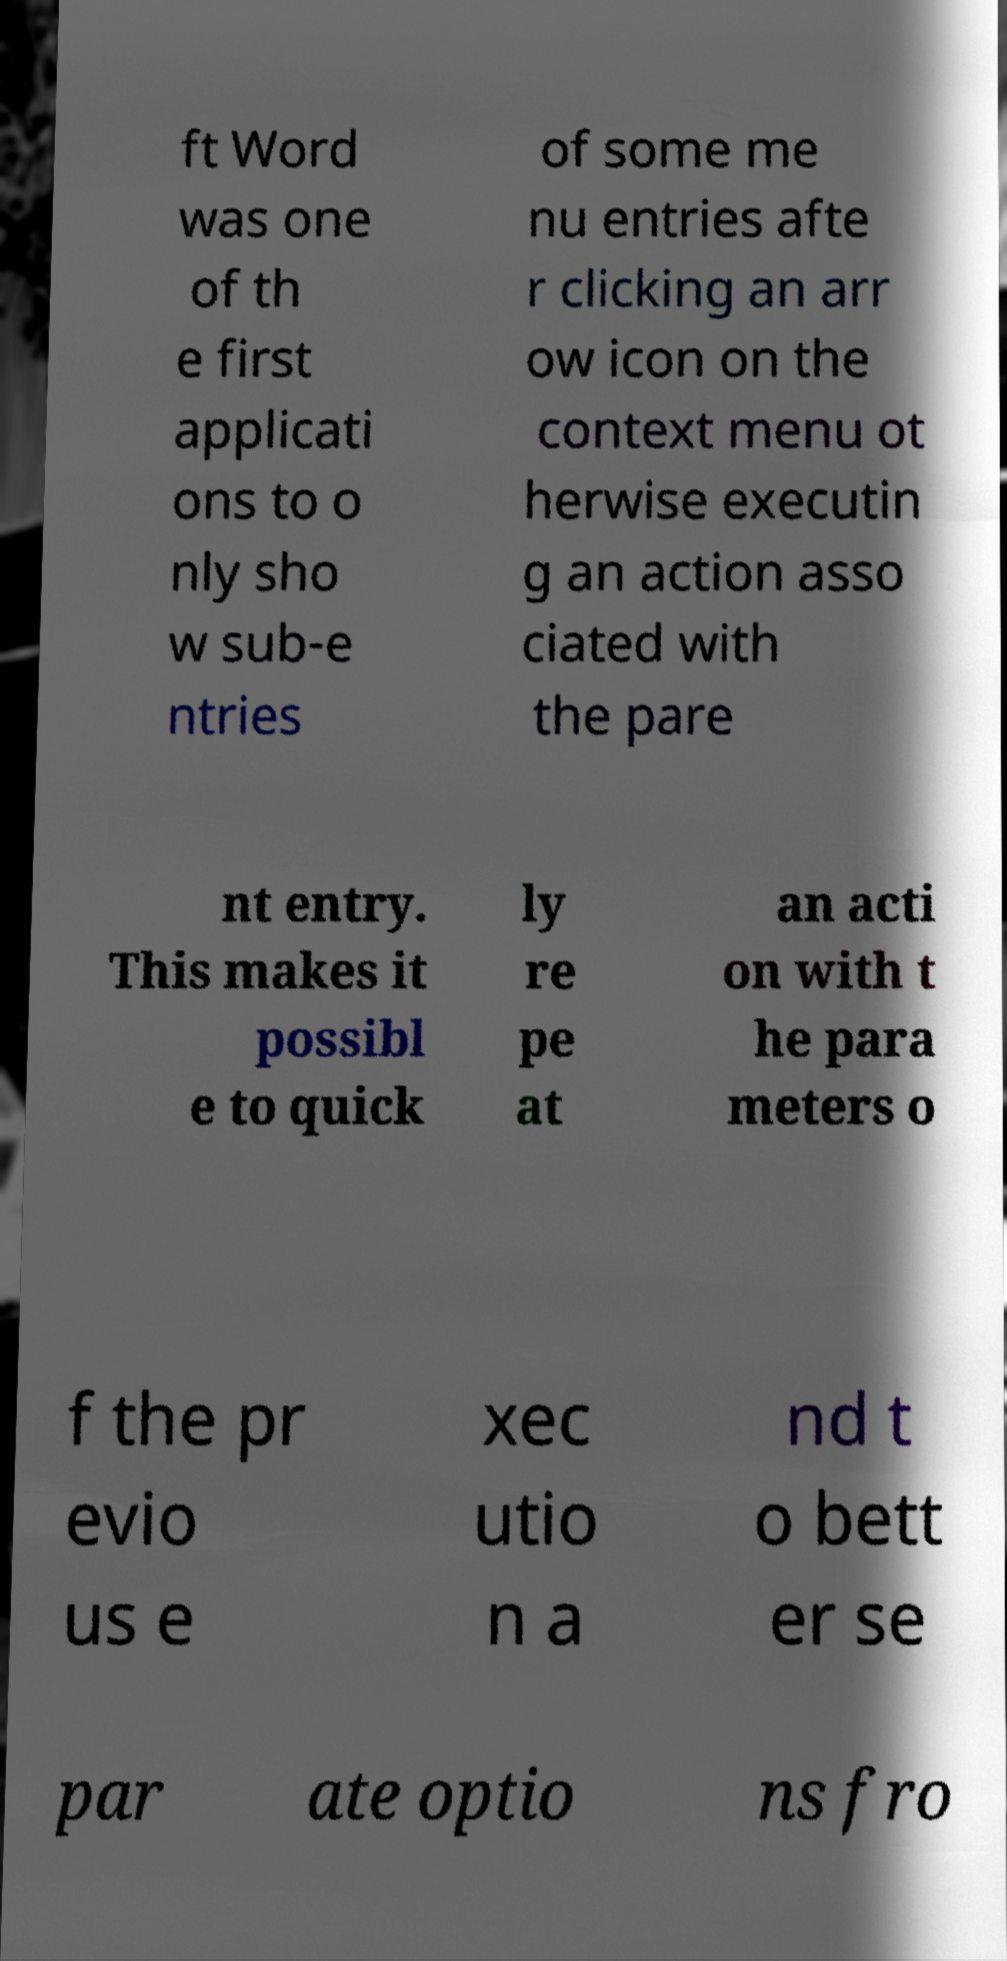Please read and relay the text visible in this image. What does it say? ft Word was one of th e first applicati ons to o nly sho w sub-e ntries of some me nu entries afte r clicking an arr ow icon on the context menu ot herwise executin g an action asso ciated with the pare nt entry. This makes it possibl e to quick ly re pe at an acti on with t he para meters o f the pr evio us e xec utio n a nd t o bett er se par ate optio ns fro 